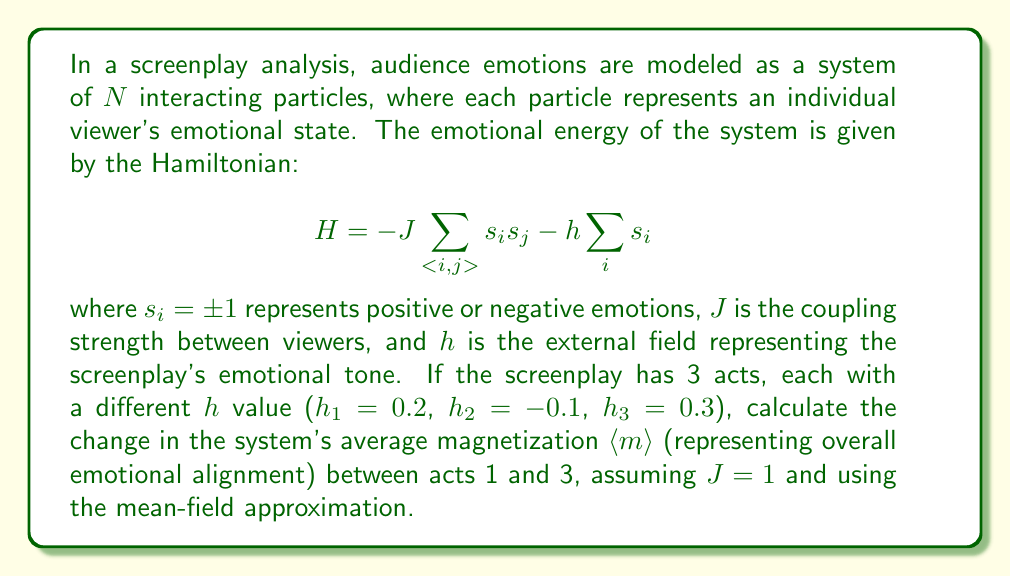Help me with this question. To solve this problem, we'll use the mean-field approximation for the Ising model, which is applicable to our audience emotion system. The steps are as follows:

1) In the mean-field approximation, the magnetization $m$ (average emotional alignment) satisfies the self-consistent equation:

   $$m = \tanh(\beta(Jzm + h))$$

   where $\beta = 1/k_BT$ (we'll assume $\beta = 1$ for simplicity), $z$ is the number of nearest neighbors (we'll use $z = 4$ for a 2D lattice), and $h$ is the external field.

2) For act 1, $h_1 = 0.2$. We need to solve:

   $$m_1 = \tanh(4m_1 + 0.2)$$

3) For act 3, $h_3 = 0.3$. We need to solve:

   $$m_3 = \tanh(4m_3 + 0.3)$$

4) These equations can be solved numerically. Using a simple iterative method:

   For act 1: $m_1 \approx 0.9892$
   For act 3: $m_3 \approx 0.9928$

5) The change in magnetization between acts 1 and 3 is:

   $$\Delta m = m_3 - m_1 = 0.9928 - 0.9892 = 0.0036$$

This positive change indicates a slight increase in overall emotional alignment towards a positive state, consistent with the more positive external field in act 3.
Answer: $\Delta \langle m \rangle = 0.0036$ 